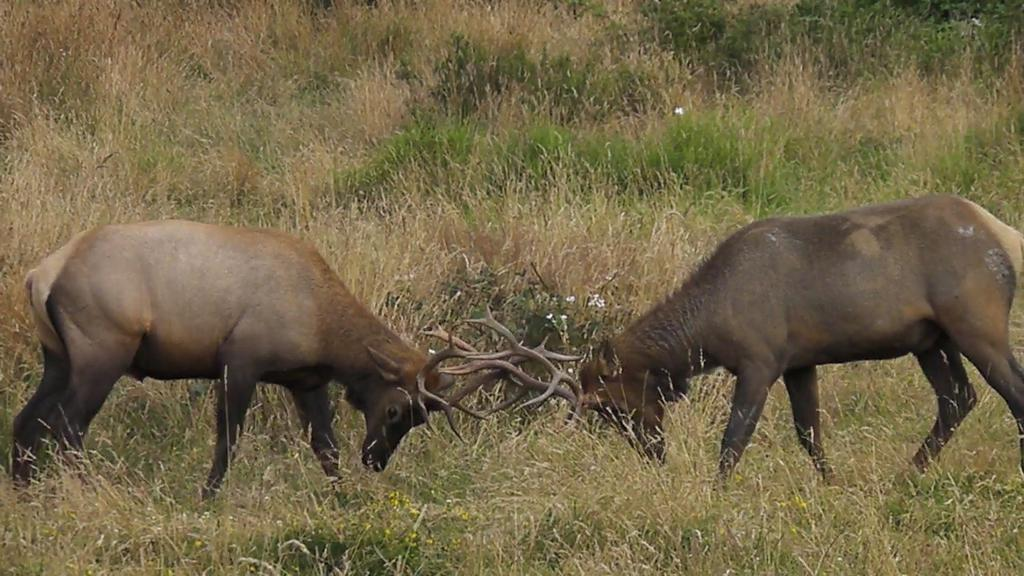What is happening between the animals in the image? The animals are fighting in the image. What type of environment is depicted in the background of the image? There is grass visible in the background of the image. What type of poison is being used by the animals in the image? There is no mention of poison in the image; the animals are fighting without any apparent weapons or substances. 